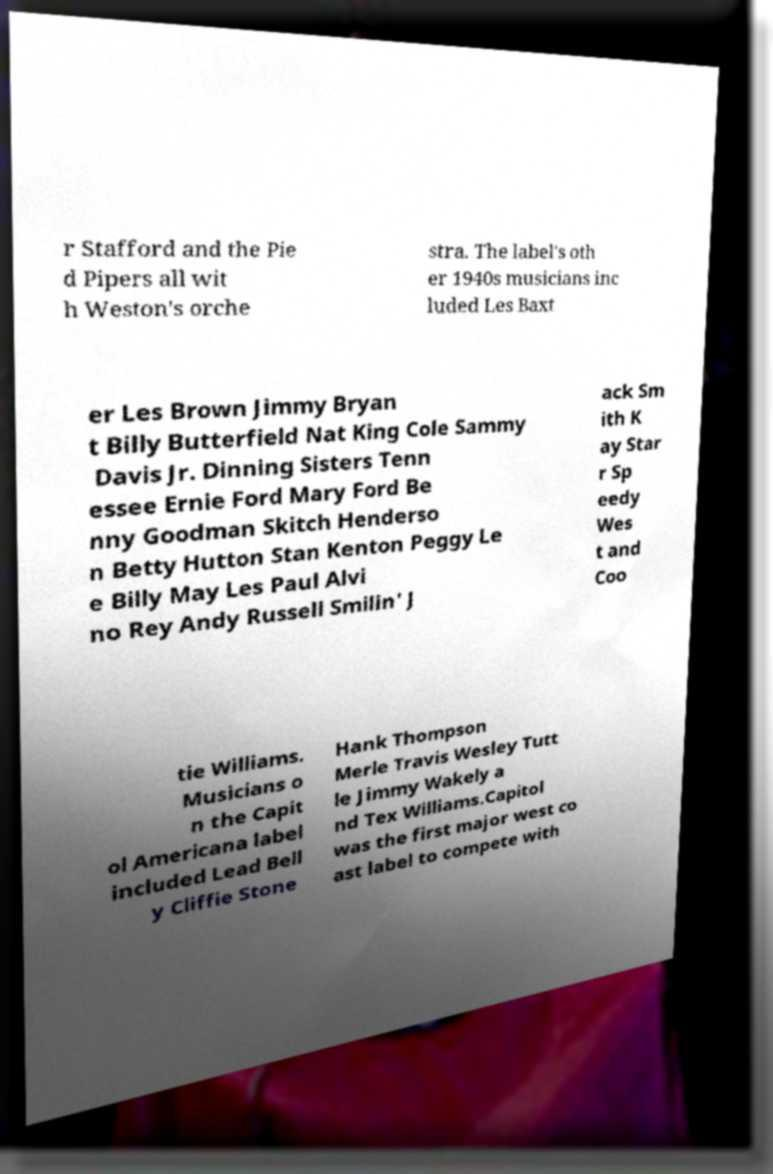What messages or text are displayed in this image? I need them in a readable, typed format. r Stafford and the Pie d Pipers all wit h Weston's orche stra. The label's oth er 1940s musicians inc luded Les Baxt er Les Brown Jimmy Bryan t Billy Butterfield Nat King Cole Sammy Davis Jr. Dinning Sisters Tenn essee Ernie Ford Mary Ford Be nny Goodman Skitch Henderso n Betty Hutton Stan Kenton Peggy Le e Billy May Les Paul Alvi no Rey Andy Russell Smilin' J ack Sm ith K ay Star r Sp eedy Wes t and Coo tie Williams. Musicians o n the Capit ol Americana label included Lead Bell y Cliffie Stone Hank Thompson Merle Travis Wesley Tutt le Jimmy Wakely a nd Tex Williams.Capitol was the first major west co ast label to compete with 